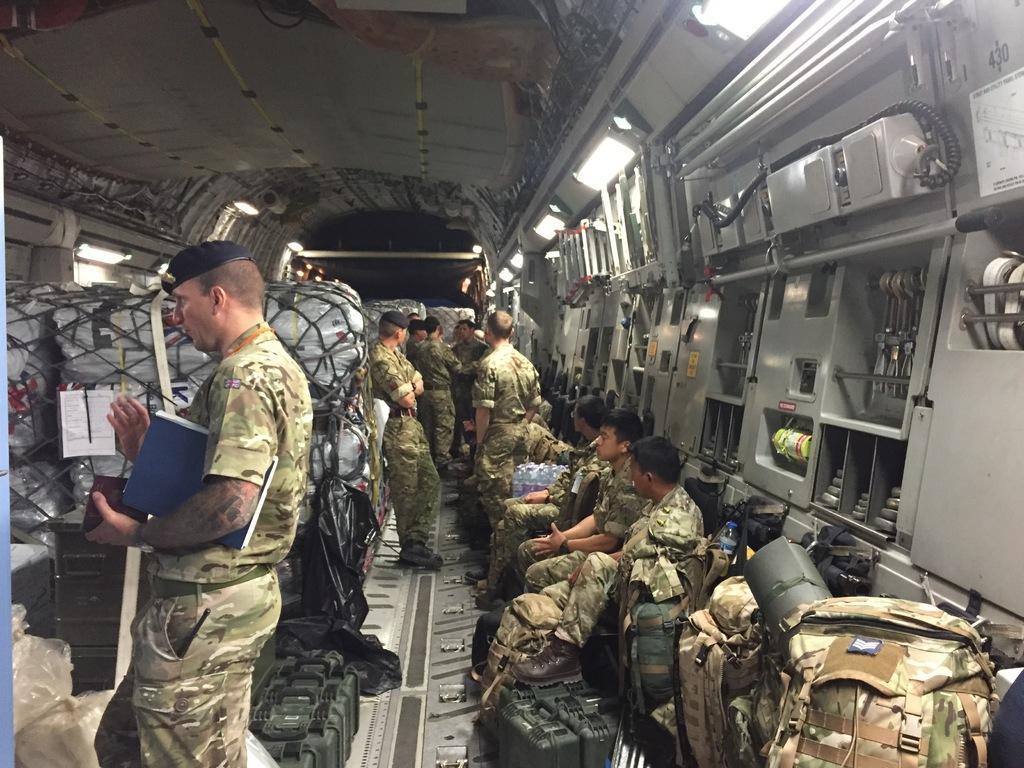Please provide a concise description of this image. In this picture we can see group of people wearing camouflage dress standing, some are sitting in an airplane, we can see some bags, objects which are in airplane and top of the picture there are some lights. 